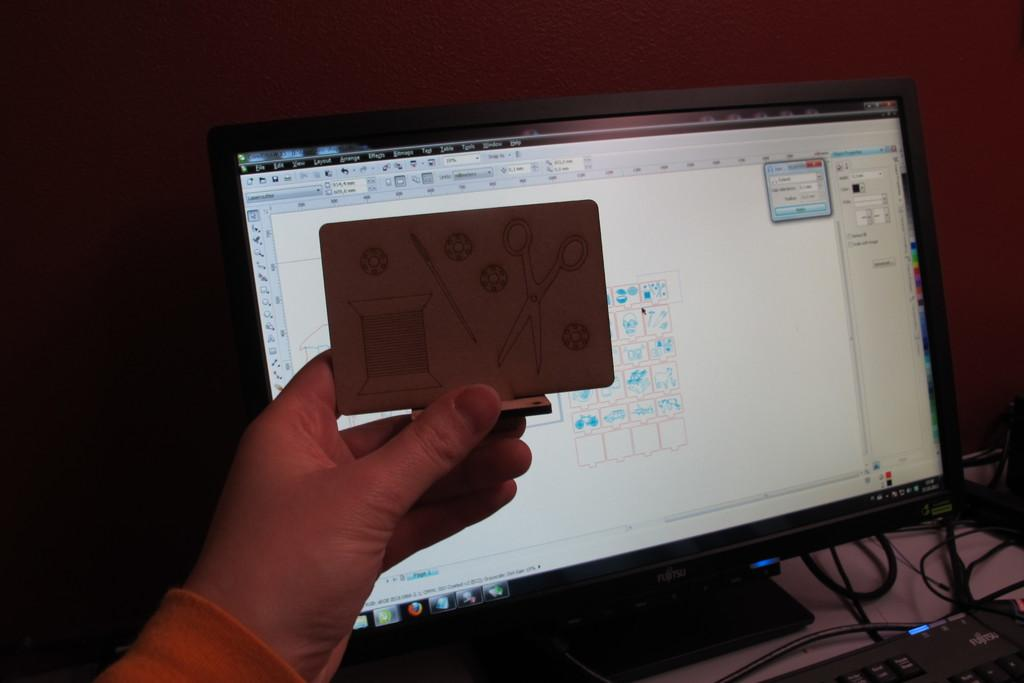What is the person's hand holding in the image? The person's hand is holding an object. What type of electronic device is present in the image? There is a monitor in the image. What else is connected to the monitor in the image? Cables are visible in the image. What is used for typing in the image? There is a keyboard in the image. What can be seen in the background of the image? There is a wall in the background of the image. What type of card is the person holding in the image? There is no card present in the image. 